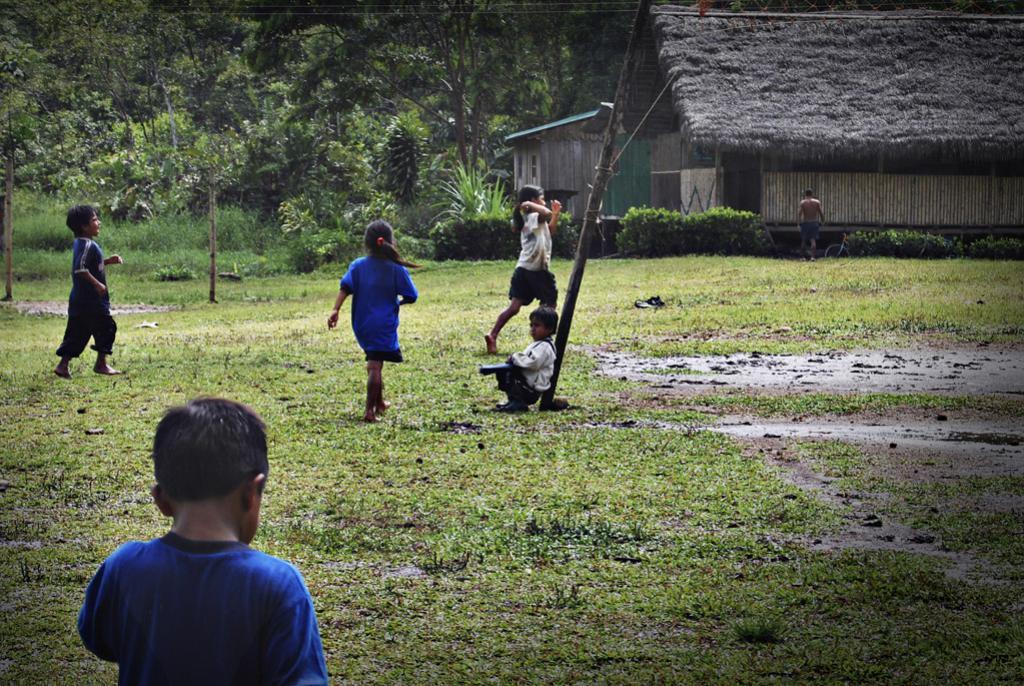Can you describe this image briefly? In the image we can see there are many children's walking and one is sitting. There is a house, made up of wood. There is a pole, grass, mud and many trees. 